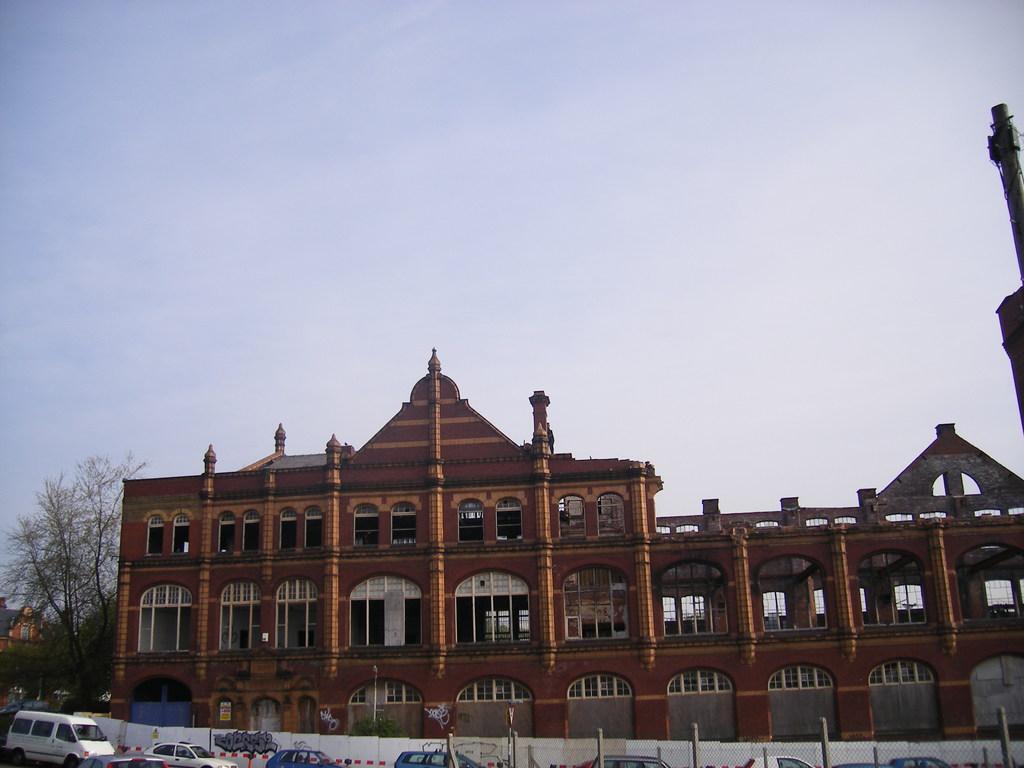In one or two sentences, can you explain what this image depicts? In this picture I can observe brown color building. There are some cars on the road in front of this building. On the left side I can observe some trees. In the background there is a sky. 